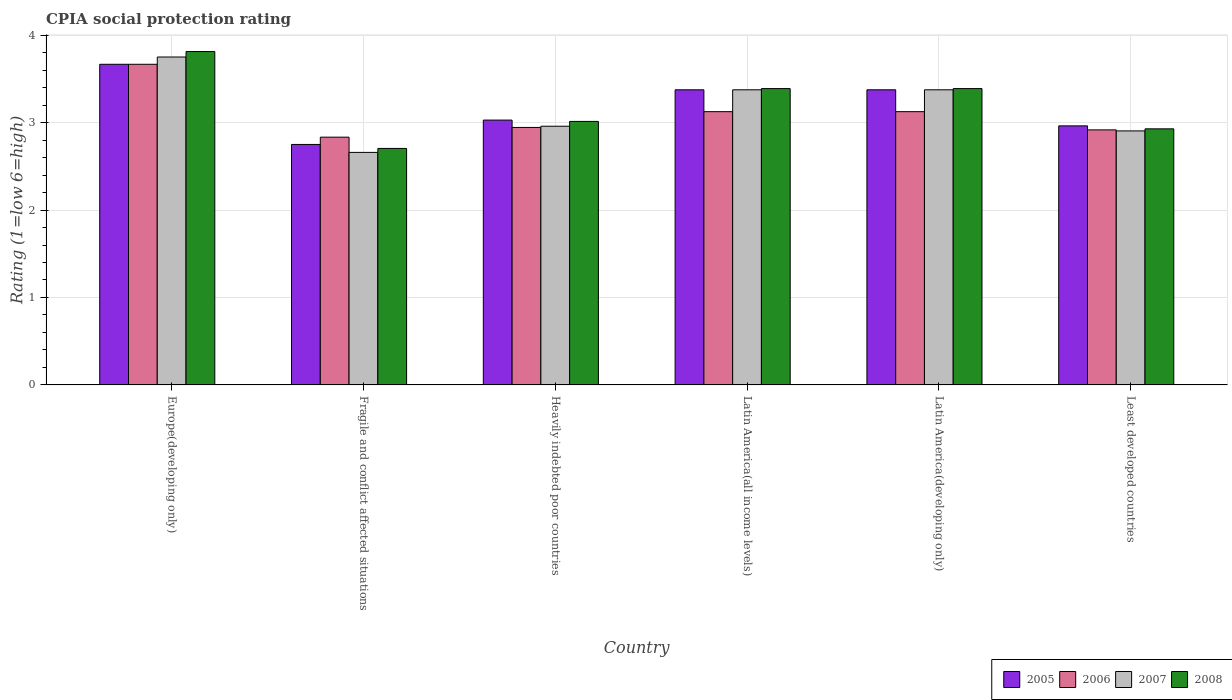Are the number of bars per tick equal to the number of legend labels?
Keep it short and to the point. Yes. How many bars are there on the 4th tick from the left?
Ensure brevity in your answer.  4. How many bars are there on the 5th tick from the right?
Offer a terse response. 4. What is the label of the 3rd group of bars from the left?
Give a very brief answer. Heavily indebted poor countries. What is the CPIA rating in 2006 in Europe(developing only)?
Your answer should be very brief. 3.67. Across all countries, what is the maximum CPIA rating in 2008?
Your answer should be compact. 3.81. Across all countries, what is the minimum CPIA rating in 2006?
Your answer should be very brief. 2.83. In which country was the CPIA rating in 2007 maximum?
Ensure brevity in your answer.  Europe(developing only). In which country was the CPIA rating in 2007 minimum?
Your answer should be very brief. Fragile and conflict affected situations. What is the total CPIA rating in 2006 in the graph?
Provide a succinct answer. 18.61. What is the difference between the CPIA rating in 2006 in Heavily indebted poor countries and that in Latin America(developing only)?
Ensure brevity in your answer.  -0.18. What is the difference between the CPIA rating in 2007 in Europe(developing only) and the CPIA rating in 2005 in Fragile and conflict affected situations?
Your answer should be compact. 1. What is the average CPIA rating in 2006 per country?
Provide a short and direct response. 3.1. What is the difference between the CPIA rating of/in 2005 and CPIA rating of/in 2006 in Latin America(developing only)?
Your response must be concise. 0.25. In how many countries, is the CPIA rating in 2005 greater than 0.2?
Your answer should be very brief. 6. What is the ratio of the CPIA rating in 2008 in Europe(developing only) to that in Latin America(developing only)?
Provide a short and direct response. 1.12. Is the CPIA rating in 2005 in Europe(developing only) less than that in Latin America(all income levels)?
Provide a succinct answer. No. What is the difference between the highest and the second highest CPIA rating in 2006?
Your answer should be very brief. -0.54. What is the difference between the highest and the lowest CPIA rating in 2007?
Make the answer very short. 1.09. Is it the case that in every country, the sum of the CPIA rating in 2006 and CPIA rating in 2007 is greater than the sum of CPIA rating in 2008 and CPIA rating in 2005?
Your response must be concise. No. Is it the case that in every country, the sum of the CPIA rating in 2007 and CPIA rating in 2008 is greater than the CPIA rating in 2005?
Your response must be concise. Yes. How many countries are there in the graph?
Provide a succinct answer. 6. What is the difference between two consecutive major ticks on the Y-axis?
Give a very brief answer. 1. Are the values on the major ticks of Y-axis written in scientific E-notation?
Ensure brevity in your answer.  No. Does the graph contain any zero values?
Give a very brief answer. No. Does the graph contain grids?
Make the answer very short. Yes. How many legend labels are there?
Your response must be concise. 4. What is the title of the graph?
Provide a succinct answer. CPIA social protection rating. Does "1982" appear as one of the legend labels in the graph?
Give a very brief answer. No. What is the label or title of the Y-axis?
Your answer should be very brief. Rating (1=low 6=high). What is the Rating (1=low 6=high) of 2005 in Europe(developing only)?
Your answer should be compact. 3.67. What is the Rating (1=low 6=high) in 2006 in Europe(developing only)?
Your answer should be compact. 3.67. What is the Rating (1=low 6=high) of 2007 in Europe(developing only)?
Provide a succinct answer. 3.75. What is the Rating (1=low 6=high) of 2008 in Europe(developing only)?
Give a very brief answer. 3.81. What is the Rating (1=low 6=high) in 2005 in Fragile and conflict affected situations?
Ensure brevity in your answer.  2.75. What is the Rating (1=low 6=high) in 2006 in Fragile and conflict affected situations?
Make the answer very short. 2.83. What is the Rating (1=low 6=high) of 2007 in Fragile and conflict affected situations?
Offer a terse response. 2.66. What is the Rating (1=low 6=high) in 2008 in Fragile and conflict affected situations?
Provide a short and direct response. 2.7. What is the Rating (1=low 6=high) of 2005 in Heavily indebted poor countries?
Offer a terse response. 3.03. What is the Rating (1=low 6=high) in 2006 in Heavily indebted poor countries?
Give a very brief answer. 2.94. What is the Rating (1=low 6=high) in 2007 in Heavily indebted poor countries?
Make the answer very short. 2.96. What is the Rating (1=low 6=high) of 2008 in Heavily indebted poor countries?
Keep it short and to the point. 3.01. What is the Rating (1=low 6=high) in 2005 in Latin America(all income levels)?
Your answer should be compact. 3.38. What is the Rating (1=low 6=high) of 2006 in Latin America(all income levels)?
Offer a terse response. 3.12. What is the Rating (1=low 6=high) in 2007 in Latin America(all income levels)?
Your response must be concise. 3.38. What is the Rating (1=low 6=high) in 2008 in Latin America(all income levels)?
Offer a terse response. 3.39. What is the Rating (1=low 6=high) in 2005 in Latin America(developing only)?
Offer a very short reply. 3.38. What is the Rating (1=low 6=high) in 2006 in Latin America(developing only)?
Offer a terse response. 3.12. What is the Rating (1=low 6=high) of 2007 in Latin America(developing only)?
Your response must be concise. 3.38. What is the Rating (1=low 6=high) of 2008 in Latin America(developing only)?
Your answer should be compact. 3.39. What is the Rating (1=low 6=high) of 2005 in Least developed countries?
Your answer should be compact. 2.96. What is the Rating (1=low 6=high) of 2006 in Least developed countries?
Offer a very short reply. 2.92. What is the Rating (1=low 6=high) in 2007 in Least developed countries?
Make the answer very short. 2.9. What is the Rating (1=low 6=high) in 2008 in Least developed countries?
Your response must be concise. 2.93. Across all countries, what is the maximum Rating (1=low 6=high) in 2005?
Keep it short and to the point. 3.67. Across all countries, what is the maximum Rating (1=low 6=high) of 2006?
Give a very brief answer. 3.67. Across all countries, what is the maximum Rating (1=low 6=high) of 2007?
Provide a short and direct response. 3.75. Across all countries, what is the maximum Rating (1=low 6=high) of 2008?
Your answer should be compact. 3.81. Across all countries, what is the minimum Rating (1=low 6=high) in 2005?
Your response must be concise. 2.75. Across all countries, what is the minimum Rating (1=low 6=high) of 2006?
Your answer should be very brief. 2.83. Across all countries, what is the minimum Rating (1=low 6=high) of 2007?
Offer a very short reply. 2.66. Across all countries, what is the minimum Rating (1=low 6=high) of 2008?
Your response must be concise. 2.7. What is the total Rating (1=low 6=high) of 2005 in the graph?
Provide a succinct answer. 19.16. What is the total Rating (1=low 6=high) of 2006 in the graph?
Provide a short and direct response. 18.61. What is the total Rating (1=low 6=high) of 2007 in the graph?
Your answer should be very brief. 19.02. What is the total Rating (1=low 6=high) in 2008 in the graph?
Offer a terse response. 19.24. What is the difference between the Rating (1=low 6=high) in 2007 in Europe(developing only) and that in Fragile and conflict affected situations?
Ensure brevity in your answer.  1.09. What is the difference between the Rating (1=low 6=high) in 2008 in Europe(developing only) and that in Fragile and conflict affected situations?
Make the answer very short. 1.11. What is the difference between the Rating (1=low 6=high) of 2005 in Europe(developing only) and that in Heavily indebted poor countries?
Offer a very short reply. 0.64. What is the difference between the Rating (1=low 6=high) of 2006 in Europe(developing only) and that in Heavily indebted poor countries?
Your answer should be compact. 0.72. What is the difference between the Rating (1=low 6=high) of 2007 in Europe(developing only) and that in Heavily indebted poor countries?
Your answer should be compact. 0.79. What is the difference between the Rating (1=low 6=high) of 2008 in Europe(developing only) and that in Heavily indebted poor countries?
Provide a succinct answer. 0.8. What is the difference between the Rating (1=low 6=high) of 2005 in Europe(developing only) and that in Latin America(all income levels)?
Offer a very short reply. 0.29. What is the difference between the Rating (1=low 6=high) in 2006 in Europe(developing only) and that in Latin America(all income levels)?
Your answer should be compact. 0.54. What is the difference between the Rating (1=low 6=high) of 2007 in Europe(developing only) and that in Latin America(all income levels)?
Offer a terse response. 0.38. What is the difference between the Rating (1=low 6=high) of 2008 in Europe(developing only) and that in Latin America(all income levels)?
Your answer should be very brief. 0.42. What is the difference between the Rating (1=low 6=high) in 2005 in Europe(developing only) and that in Latin America(developing only)?
Keep it short and to the point. 0.29. What is the difference between the Rating (1=low 6=high) of 2006 in Europe(developing only) and that in Latin America(developing only)?
Offer a very short reply. 0.54. What is the difference between the Rating (1=low 6=high) of 2008 in Europe(developing only) and that in Latin America(developing only)?
Offer a very short reply. 0.42. What is the difference between the Rating (1=low 6=high) in 2005 in Europe(developing only) and that in Least developed countries?
Your answer should be compact. 0.7. What is the difference between the Rating (1=low 6=high) in 2007 in Europe(developing only) and that in Least developed countries?
Ensure brevity in your answer.  0.85. What is the difference between the Rating (1=low 6=high) of 2008 in Europe(developing only) and that in Least developed countries?
Your answer should be very brief. 0.88. What is the difference between the Rating (1=low 6=high) in 2005 in Fragile and conflict affected situations and that in Heavily indebted poor countries?
Give a very brief answer. -0.28. What is the difference between the Rating (1=low 6=high) in 2006 in Fragile and conflict affected situations and that in Heavily indebted poor countries?
Your answer should be very brief. -0.11. What is the difference between the Rating (1=low 6=high) of 2007 in Fragile and conflict affected situations and that in Heavily indebted poor countries?
Your response must be concise. -0.3. What is the difference between the Rating (1=low 6=high) in 2008 in Fragile and conflict affected situations and that in Heavily indebted poor countries?
Your answer should be very brief. -0.31. What is the difference between the Rating (1=low 6=high) of 2005 in Fragile and conflict affected situations and that in Latin America(all income levels)?
Make the answer very short. -0.62. What is the difference between the Rating (1=low 6=high) in 2006 in Fragile and conflict affected situations and that in Latin America(all income levels)?
Ensure brevity in your answer.  -0.29. What is the difference between the Rating (1=low 6=high) of 2007 in Fragile and conflict affected situations and that in Latin America(all income levels)?
Your response must be concise. -0.72. What is the difference between the Rating (1=low 6=high) in 2008 in Fragile and conflict affected situations and that in Latin America(all income levels)?
Your answer should be very brief. -0.68. What is the difference between the Rating (1=low 6=high) in 2005 in Fragile and conflict affected situations and that in Latin America(developing only)?
Your answer should be very brief. -0.62. What is the difference between the Rating (1=low 6=high) of 2006 in Fragile and conflict affected situations and that in Latin America(developing only)?
Keep it short and to the point. -0.29. What is the difference between the Rating (1=low 6=high) in 2007 in Fragile and conflict affected situations and that in Latin America(developing only)?
Provide a succinct answer. -0.72. What is the difference between the Rating (1=low 6=high) in 2008 in Fragile and conflict affected situations and that in Latin America(developing only)?
Keep it short and to the point. -0.68. What is the difference between the Rating (1=low 6=high) in 2005 in Fragile and conflict affected situations and that in Least developed countries?
Make the answer very short. -0.21. What is the difference between the Rating (1=low 6=high) in 2006 in Fragile and conflict affected situations and that in Least developed countries?
Ensure brevity in your answer.  -0.08. What is the difference between the Rating (1=low 6=high) of 2007 in Fragile and conflict affected situations and that in Least developed countries?
Your answer should be very brief. -0.25. What is the difference between the Rating (1=low 6=high) in 2008 in Fragile and conflict affected situations and that in Least developed countries?
Offer a terse response. -0.22. What is the difference between the Rating (1=low 6=high) of 2005 in Heavily indebted poor countries and that in Latin America(all income levels)?
Keep it short and to the point. -0.35. What is the difference between the Rating (1=low 6=high) in 2006 in Heavily indebted poor countries and that in Latin America(all income levels)?
Provide a short and direct response. -0.18. What is the difference between the Rating (1=low 6=high) in 2007 in Heavily indebted poor countries and that in Latin America(all income levels)?
Provide a short and direct response. -0.42. What is the difference between the Rating (1=low 6=high) of 2008 in Heavily indebted poor countries and that in Latin America(all income levels)?
Your response must be concise. -0.38. What is the difference between the Rating (1=low 6=high) in 2005 in Heavily indebted poor countries and that in Latin America(developing only)?
Offer a very short reply. -0.35. What is the difference between the Rating (1=low 6=high) in 2006 in Heavily indebted poor countries and that in Latin America(developing only)?
Your answer should be compact. -0.18. What is the difference between the Rating (1=low 6=high) of 2007 in Heavily indebted poor countries and that in Latin America(developing only)?
Offer a very short reply. -0.42. What is the difference between the Rating (1=low 6=high) of 2008 in Heavily indebted poor countries and that in Latin America(developing only)?
Your response must be concise. -0.38. What is the difference between the Rating (1=low 6=high) of 2005 in Heavily indebted poor countries and that in Least developed countries?
Offer a very short reply. 0.07. What is the difference between the Rating (1=low 6=high) in 2006 in Heavily indebted poor countries and that in Least developed countries?
Make the answer very short. 0.03. What is the difference between the Rating (1=low 6=high) in 2007 in Heavily indebted poor countries and that in Least developed countries?
Provide a succinct answer. 0.05. What is the difference between the Rating (1=low 6=high) in 2008 in Heavily indebted poor countries and that in Least developed countries?
Offer a terse response. 0.08. What is the difference between the Rating (1=low 6=high) in 2005 in Latin America(all income levels) and that in Latin America(developing only)?
Ensure brevity in your answer.  0. What is the difference between the Rating (1=low 6=high) in 2006 in Latin America(all income levels) and that in Latin America(developing only)?
Your answer should be very brief. 0. What is the difference between the Rating (1=low 6=high) of 2007 in Latin America(all income levels) and that in Latin America(developing only)?
Your answer should be very brief. 0. What is the difference between the Rating (1=low 6=high) in 2008 in Latin America(all income levels) and that in Latin America(developing only)?
Your answer should be very brief. 0. What is the difference between the Rating (1=low 6=high) in 2005 in Latin America(all income levels) and that in Least developed countries?
Your answer should be very brief. 0.41. What is the difference between the Rating (1=low 6=high) in 2006 in Latin America(all income levels) and that in Least developed countries?
Your answer should be very brief. 0.21. What is the difference between the Rating (1=low 6=high) of 2007 in Latin America(all income levels) and that in Least developed countries?
Ensure brevity in your answer.  0.47. What is the difference between the Rating (1=low 6=high) in 2008 in Latin America(all income levels) and that in Least developed countries?
Make the answer very short. 0.46. What is the difference between the Rating (1=low 6=high) of 2005 in Latin America(developing only) and that in Least developed countries?
Your answer should be very brief. 0.41. What is the difference between the Rating (1=low 6=high) of 2006 in Latin America(developing only) and that in Least developed countries?
Your answer should be very brief. 0.21. What is the difference between the Rating (1=low 6=high) of 2007 in Latin America(developing only) and that in Least developed countries?
Make the answer very short. 0.47. What is the difference between the Rating (1=low 6=high) in 2008 in Latin America(developing only) and that in Least developed countries?
Your answer should be very brief. 0.46. What is the difference between the Rating (1=low 6=high) in 2005 in Europe(developing only) and the Rating (1=low 6=high) in 2006 in Fragile and conflict affected situations?
Offer a terse response. 0.83. What is the difference between the Rating (1=low 6=high) of 2005 in Europe(developing only) and the Rating (1=low 6=high) of 2007 in Fragile and conflict affected situations?
Give a very brief answer. 1.01. What is the difference between the Rating (1=low 6=high) in 2005 in Europe(developing only) and the Rating (1=low 6=high) in 2008 in Fragile and conflict affected situations?
Keep it short and to the point. 0.96. What is the difference between the Rating (1=low 6=high) of 2006 in Europe(developing only) and the Rating (1=low 6=high) of 2007 in Fragile and conflict affected situations?
Offer a very short reply. 1.01. What is the difference between the Rating (1=low 6=high) in 2006 in Europe(developing only) and the Rating (1=low 6=high) in 2008 in Fragile and conflict affected situations?
Keep it short and to the point. 0.96. What is the difference between the Rating (1=low 6=high) in 2007 in Europe(developing only) and the Rating (1=low 6=high) in 2008 in Fragile and conflict affected situations?
Your answer should be compact. 1.05. What is the difference between the Rating (1=low 6=high) in 2005 in Europe(developing only) and the Rating (1=low 6=high) in 2006 in Heavily indebted poor countries?
Your answer should be very brief. 0.72. What is the difference between the Rating (1=low 6=high) in 2005 in Europe(developing only) and the Rating (1=low 6=high) in 2007 in Heavily indebted poor countries?
Provide a succinct answer. 0.71. What is the difference between the Rating (1=low 6=high) in 2005 in Europe(developing only) and the Rating (1=low 6=high) in 2008 in Heavily indebted poor countries?
Provide a short and direct response. 0.65. What is the difference between the Rating (1=low 6=high) in 2006 in Europe(developing only) and the Rating (1=low 6=high) in 2007 in Heavily indebted poor countries?
Offer a very short reply. 0.71. What is the difference between the Rating (1=low 6=high) of 2006 in Europe(developing only) and the Rating (1=low 6=high) of 2008 in Heavily indebted poor countries?
Keep it short and to the point. 0.65. What is the difference between the Rating (1=low 6=high) in 2007 in Europe(developing only) and the Rating (1=low 6=high) in 2008 in Heavily indebted poor countries?
Offer a very short reply. 0.74. What is the difference between the Rating (1=low 6=high) in 2005 in Europe(developing only) and the Rating (1=low 6=high) in 2006 in Latin America(all income levels)?
Provide a short and direct response. 0.54. What is the difference between the Rating (1=low 6=high) of 2005 in Europe(developing only) and the Rating (1=low 6=high) of 2007 in Latin America(all income levels)?
Make the answer very short. 0.29. What is the difference between the Rating (1=low 6=high) in 2005 in Europe(developing only) and the Rating (1=low 6=high) in 2008 in Latin America(all income levels)?
Provide a short and direct response. 0.28. What is the difference between the Rating (1=low 6=high) in 2006 in Europe(developing only) and the Rating (1=low 6=high) in 2007 in Latin America(all income levels)?
Keep it short and to the point. 0.29. What is the difference between the Rating (1=low 6=high) in 2006 in Europe(developing only) and the Rating (1=low 6=high) in 2008 in Latin America(all income levels)?
Provide a short and direct response. 0.28. What is the difference between the Rating (1=low 6=high) of 2007 in Europe(developing only) and the Rating (1=low 6=high) of 2008 in Latin America(all income levels)?
Give a very brief answer. 0.36. What is the difference between the Rating (1=low 6=high) in 2005 in Europe(developing only) and the Rating (1=low 6=high) in 2006 in Latin America(developing only)?
Provide a succinct answer. 0.54. What is the difference between the Rating (1=low 6=high) in 2005 in Europe(developing only) and the Rating (1=low 6=high) in 2007 in Latin America(developing only)?
Ensure brevity in your answer.  0.29. What is the difference between the Rating (1=low 6=high) of 2005 in Europe(developing only) and the Rating (1=low 6=high) of 2008 in Latin America(developing only)?
Your answer should be compact. 0.28. What is the difference between the Rating (1=low 6=high) of 2006 in Europe(developing only) and the Rating (1=low 6=high) of 2007 in Latin America(developing only)?
Provide a succinct answer. 0.29. What is the difference between the Rating (1=low 6=high) of 2006 in Europe(developing only) and the Rating (1=low 6=high) of 2008 in Latin America(developing only)?
Your response must be concise. 0.28. What is the difference between the Rating (1=low 6=high) of 2007 in Europe(developing only) and the Rating (1=low 6=high) of 2008 in Latin America(developing only)?
Provide a succinct answer. 0.36. What is the difference between the Rating (1=low 6=high) of 2005 in Europe(developing only) and the Rating (1=low 6=high) of 2006 in Least developed countries?
Keep it short and to the point. 0.75. What is the difference between the Rating (1=low 6=high) in 2005 in Europe(developing only) and the Rating (1=low 6=high) in 2007 in Least developed countries?
Make the answer very short. 0.76. What is the difference between the Rating (1=low 6=high) in 2005 in Europe(developing only) and the Rating (1=low 6=high) in 2008 in Least developed countries?
Ensure brevity in your answer.  0.74. What is the difference between the Rating (1=low 6=high) in 2006 in Europe(developing only) and the Rating (1=low 6=high) in 2007 in Least developed countries?
Provide a succinct answer. 0.76. What is the difference between the Rating (1=low 6=high) in 2006 in Europe(developing only) and the Rating (1=low 6=high) in 2008 in Least developed countries?
Your answer should be very brief. 0.74. What is the difference between the Rating (1=low 6=high) in 2007 in Europe(developing only) and the Rating (1=low 6=high) in 2008 in Least developed countries?
Give a very brief answer. 0.82. What is the difference between the Rating (1=low 6=high) of 2005 in Fragile and conflict affected situations and the Rating (1=low 6=high) of 2006 in Heavily indebted poor countries?
Give a very brief answer. -0.19. What is the difference between the Rating (1=low 6=high) of 2005 in Fragile and conflict affected situations and the Rating (1=low 6=high) of 2007 in Heavily indebted poor countries?
Your response must be concise. -0.21. What is the difference between the Rating (1=low 6=high) of 2005 in Fragile and conflict affected situations and the Rating (1=low 6=high) of 2008 in Heavily indebted poor countries?
Your response must be concise. -0.26. What is the difference between the Rating (1=low 6=high) in 2006 in Fragile and conflict affected situations and the Rating (1=low 6=high) in 2007 in Heavily indebted poor countries?
Provide a succinct answer. -0.12. What is the difference between the Rating (1=low 6=high) of 2006 in Fragile and conflict affected situations and the Rating (1=low 6=high) of 2008 in Heavily indebted poor countries?
Offer a very short reply. -0.18. What is the difference between the Rating (1=low 6=high) of 2007 in Fragile and conflict affected situations and the Rating (1=low 6=high) of 2008 in Heavily indebted poor countries?
Keep it short and to the point. -0.35. What is the difference between the Rating (1=low 6=high) in 2005 in Fragile and conflict affected situations and the Rating (1=low 6=high) in 2006 in Latin America(all income levels)?
Keep it short and to the point. -0.38. What is the difference between the Rating (1=low 6=high) in 2005 in Fragile and conflict affected situations and the Rating (1=low 6=high) in 2007 in Latin America(all income levels)?
Your answer should be very brief. -0.62. What is the difference between the Rating (1=low 6=high) of 2005 in Fragile and conflict affected situations and the Rating (1=low 6=high) of 2008 in Latin America(all income levels)?
Your response must be concise. -0.64. What is the difference between the Rating (1=low 6=high) in 2006 in Fragile and conflict affected situations and the Rating (1=low 6=high) in 2007 in Latin America(all income levels)?
Offer a terse response. -0.54. What is the difference between the Rating (1=low 6=high) of 2006 in Fragile and conflict affected situations and the Rating (1=low 6=high) of 2008 in Latin America(all income levels)?
Offer a terse response. -0.56. What is the difference between the Rating (1=low 6=high) of 2007 in Fragile and conflict affected situations and the Rating (1=low 6=high) of 2008 in Latin America(all income levels)?
Keep it short and to the point. -0.73. What is the difference between the Rating (1=low 6=high) of 2005 in Fragile and conflict affected situations and the Rating (1=low 6=high) of 2006 in Latin America(developing only)?
Ensure brevity in your answer.  -0.38. What is the difference between the Rating (1=low 6=high) in 2005 in Fragile and conflict affected situations and the Rating (1=low 6=high) in 2007 in Latin America(developing only)?
Offer a terse response. -0.62. What is the difference between the Rating (1=low 6=high) of 2005 in Fragile and conflict affected situations and the Rating (1=low 6=high) of 2008 in Latin America(developing only)?
Make the answer very short. -0.64. What is the difference between the Rating (1=low 6=high) in 2006 in Fragile and conflict affected situations and the Rating (1=low 6=high) in 2007 in Latin America(developing only)?
Provide a short and direct response. -0.54. What is the difference between the Rating (1=low 6=high) in 2006 in Fragile and conflict affected situations and the Rating (1=low 6=high) in 2008 in Latin America(developing only)?
Give a very brief answer. -0.56. What is the difference between the Rating (1=low 6=high) in 2007 in Fragile and conflict affected situations and the Rating (1=low 6=high) in 2008 in Latin America(developing only)?
Your response must be concise. -0.73. What is the difference between the Rating (1=low 6=high) of 2005 in Fragile and conflict affected situations and the Rating (1=low 6=high) of 2006 in Least developed countries?
Keep it short and to the point. -0.17. What is the difference between the Rating (1=low 6=high) of 2005 in Fragile and conflict affected situations and the Rating (1=low 6=high) of 2007 in Least developed countries?
Provide a succinct answer. -0.15. What is the difference between the Rating (1=low 6=high) of 2005 in Fragile and conflict affected situations and the Rating (1=low 6=high) of 2008 in Least developed countries?
Make the answer very short. -0.18. What is the difference between the Rating (1=low 6=high) of 2006 in Fragile and conflict affected situations and the Rating (1=low 6=high) of 2007 in Least developed countries?
Your answer should be very brief. -0.07. What is the difference between the Rating (1=low 6=high) in 2006 in Fragile and conflict affected situations and the Rating (1=low 6=high) in 2008 in Least developed countries?
Provide a short and direct response. -0.1. What is the difference between the Rating (1=low 6=high) in 2007 in Fragile and conflict affected situations and the Rating (1=low 6=high) in 2008 in Least developed countries?
Your response must be concise. -0.27. What is the difference between the Rating (1=low 6=high) of 2005 in Heavily indebted poor countries and the Rating (1=low 6=high) of 2006 in Latin America(all income levels)?
Make the answer very short. -0.1. What is the difference between the Rating (1=low 6=high) of 2005 in Heavily indebted poor countries and the Rating (1=low 6=high) of 2007 in Latin America(all income levels)?
Give a very brief answer. -0.35. What is the difference between the Rating (1=low 6=high) of 2005 in Heavily indebted poor countries and the Rating (1=low 6=high) of 2008 in Latin America(all income levels)?
Offer a very short reply. -0.36. What is the difference between the Rating (1=low 6=high) in 2006 in Heavily indebted poor countries and the Rating (1=low 6=high) in 2007 in Latin America(all income levels)?
Keep it short and to the point. -0.43. What is the difference between the Rating (1=low 6=high) of 2006 in Heavily indebted poor countries and the Rating (1=low 6=high) of 2008 in Latin America(all income levels)?
Your answer should be compact. -0.44. What is the difference between the Rating (1=low 6=high) in 2007 in Heavily indebted poor countries and the Rating (1=low 6=high) in 2008 in Latin America(all income levels)?
Provide a succinct answer. -0.43. What is the difference between the Rating (1=low 6=high) of 2005 in Heavily indebted poor countries and the Rating (1=low 6=high) of 2006 in Latin America(developing only)?
Your answer should be compact. -0.1. What is the difference between the Rating (1=low 6=high) in 2005 in Heavily indebted poor countries and the Rating (1=low 6=high) in 2007 in Latin America(developing only)?
Your response must be concise. -0.35. What is the difference between the Rating (1=low 6=high) in 2005 in Heavily indebted poor countries and the Rating (1=low 6=high) in 2008 in Latin America(developing only)?
Your response must be concise. -0.36. What is the difference between the Rating (1=low 6=high) of 2006 in Heavily indebted poor countries and the Rating (1=low 6=high) of 2007 in Latin America(developing only)?
Your answer should be very brief. -0.43. What is the difference between the Rating (1=low 6=high) in 2006 in Heavily indebted poor countries and the Rating (1=low 6=high) in 2008 in Latin America(developing only)?
Give a very brief answer. -0.44. What is the difference between the Rating (1=low 6=high) in 2007 in Heavily indebted poor countries and the Rating (1=low 6=high) in 2008 in Latin America(developing only)?
Offer a terse response. -0.43. What is the difference between the Rating (1=low 6=high) in 2005 in Heavily indebted poor countries and the Rating (1=low 6=high) in 2006 in Least developed countries?
Your response must be concise. 0.11. What is the difference between the Rating (1=low 6=high) in 2005 in Heavily indebted poor countries and the Rating (1=low 6=high) in 2007 in Least developed countries?
Keep it short and to the point. 0.12. What is the difference between the Rating (1=low 6=high) of 2005 in Heavily indebted poor countries and the Rating (1=low 6=high) of 2008 in Least developed countries?
Provide a succinct answer. 0.1. What is the difference between the Rating (1=low 6=high) in 2006 in Heavily indebted poor countries and the Rating (1=low 6=high) in 2007 in Least developed countries?
Your answer should be very brief. 0.04. What is the difference between the Rating (1=low 6=high) of 2006 in Heavily indebted poor countries and the Rating (1=low 6=high) of 2008 in Least developed countries?
Give a very brief answer. 0.02. What is the difference between the Rating (1=low 6=high) in 2007 in Heavily indebted poor countries and the Rating (1=low 6=high) in 2008 in Least developed countries?
Make the answer very short. 0.03. What is the difference between the Rating (1=low 6=high) of 2005 in Latin America(all income levels) and the Rating (1=low 6=high) of 2007 in Latin America(developing only)?
Offer a terse response. 0. What is the difference between the Rating (1=low 6=high) of 2005 in Latin America(all income levels) and the Rating (1=low 6=high) of 2008 in Latin America(developing only)?
Your response must be concise. -0.01. What is the difference between the Rating (1=low 6=high) in 2006 in Latin America(all income levels) and the Rating (1=low 6=high) in 2007 in Latin America(developing only)?
Your response must be concise. -0.25. What is the difference between the Rating (1=low 6=high) of 2006 in Latin America(all income levels) and the Rating (1=low 6=high) of 2008 in Latin America(developing only)?
Your response must be concise. -0.26. What is the difference between the Rating (1=low 6=high) in 2007 in Latin America(all income levels) and the Rating (1=low 6=high) in 2008 in Latin America(developing only)?
Your answer should be compact. -0.01. What is the difference between the Rating (1=low 6=high) in 2005 in Latin America(all income levels) and the Rating (1=low 6=high) in 2006 in Least developed countries?
Give a very brief answer. 0.46. What is the difference between the Rating (1=low 6=high) in 2005 in Latin America(all income levels) and the Rating (1=low 6=high) in 2007 in Least developed countries?
Keep it short and to the point. 0.47. What is the difference between the Rating (1=low 6=high) in 2005 in Latin America(all income levels) and the Rating (1=low 6=high) in 2008 in Least developed countries?
Keep it short and to the point. 0.45. What is the difference between the Rating (1=low 6=high) in 2006 in Latin America(all income levels) and the Rating (1=low 6=high) in 2007 in Least developed countries?
Your answer should be very brief. 0.22. What is the difference between the Rating (1=low 6=high) of 2006 in Latin America(all income levels) and the Rating (1=low 6=high) of 2008 in Least developed countries?
Offer a very short reply. 0.2. What is the difference between the Rating (1=low 6=high) in 2007 in Latin America(all income levels) and the Rating (1=low 6=high) in 2008 in Least developed countries?
Keep it short and to the point. 0.45. What is the difference between the Rating (1=low 6=high) in 2005 in Latin America(developing only) and the Rating (1=low 6=high) in 2006 in Least developed countries?
Make the answer very short. 0.46. What is the difference between the Rating (1=low 6=high) of 2005 in Latin America(developing only) and the Rating (1=low 6=high) of 2007 in Least developed countries?
Your answer should be very brief. 0.47. What is the difference between the Rating (1=low 6=high) of 2005 in Latin America(developing only) and the Rating (1=low 6=high) of 2008 in Least developed countries?
Your response must be concise. 0.45. What is the difference between the Rating (1=low 6=high) of 2006 in Latin America(developing only) and the Rating (1=low 6=high) of 2007 in Least developed countries?
Your answer should be compact. 0.22. What is the difference between the Rating (1=low 6=high) of 2006 in Latin America(developing only) and the Rating (1=low 6=high) of 2008 in Least developed countries?
Ensure brevity in your answer.  0.2. What is the difference between the Rating (1=low 6=high) of 2007 in Latin America(developing only) and the Rating (1=low 6=high) of 2008 in Least developed countries?
Offer a terse response. 0.45. What is the average Rating (1=low 6=high) of 2005 per country?
Make the answer very short. 3.19. What is the average Rating (1=low 6=high) in 2006 per country?
Make the answer very short. 3.1. What is the average Rating (1=low 6=high) of 2007 per country?
Ensure brevity in your answer.  3.17. What is the average Rating (1=low 6=high) in 2008 per country?
Ensure brevity in your answer.  3.21. What is the difference between the Rating (1=low 6=high) of 2005 and Rating (1=low 6=high) of 2007 in Europe(developing only)?
Your answer should be compact. -0.08. What is the difference between the Rating (1=low 6=high) in 2005 and Rating (1=low 6=high) in 2008 in Europe(developing only)?
Give a very brief answer. -0.15. What is the difference between the Rating (1=low 6=high) of 2006 and Rating (1=low 6=high) of 2007 in Europe(developing only)?
Make the answer very short. -0.08. What is the difference between the Rating (1=low 6=high) of 2006 and Rating (1=low 6=high) of 2008 in Europe(developing only)?
Make the answer very short. -0.15. What is the difference between the Rating (1=low 6=high) in 2007 and Rating (1=low 6=high) in 2008 in Europe(developing only)?
Your response must be concise. -0.06. What is the difference between the Rating (1=low 6=high) in 2005 and Rating (1=low 6=high) in 2006 in Fragile and conflict affected situations?
Provide a succinct answer. -0.08. What is the difference between the Rating (1=low 6=high) in 2005 and Rating (1=low 6=high) in 2007 in Fragile and conflict affected situations?
Your answer should be very brief. 0.09. What is the difference between the Rating (1=low 6=high) in 2005 and Rating (1=low 6=high) in 2008 in Fragile and conflict affected situations?
Keep it short and to the point. 0.05. What is the difference between the Rating (1=low 6=high) in 2006 and Rating (1=low 6=high) in 2007 in Fragile and conflict affected situations?
Give a very brief answer. 0.17. What is the difference between the Rating (1=low 6=high) in 2006 and Rating (1=low 6=high) in 2008 in Fragile and conflict affected situations?
Ensure brevity in your answer.  0.13. What is the difference between the Rating (1=low 6=high) in 2007 and Rating (1=low 6=high) in 2008 in Fragile and conflict affected situations?
Give a very brief answer. -0.05. What is the difference between the Rating (1=low 6=high) in 2005 and Rating (1=low 6=high) in 2006 in Heavily indebted poor countries?
Ensure brevity in your answer.  0.08. What is the difference between the Rating (1=low 6=high) of 2005 and Rating (1=low 6=high) of 2007 in Heavily indebted poor countries?
Give a very brief answer. 0.07. What is the difference between the Rating (1=low 6=high) in 2005 and Rating (1=low 6=high) in 2008 in Heavily indebted poor countries?
Provide a short and direct response. 0.02. What is the difference between the Rating (1=low 6=high) in 2006 and Rating (1=low 6=high) in 2007 in Heavily indebted poor countries?
Make the answer very short. -0.01. What is the difference between the Rating (1=low 6=high) of 2006 and Rating (1=low 6=high) of 2008 in Heavily indebted poor countries?
Give a very brief answer. -0.07. What is the difference between the Rating (1=low 6=high) of 2007 and Rating (1=low 6=high) of 2008 in Heavily indebted poor countries?
Keep it short and to the point. -0.06. What is the difference between the Rating (1=low 6=high) in 2005 and Rating (1=low 6=high) in 2007 in Latin America(all income levels)?
Offer a very short reply. 0. What is the difference between the Rating (1=low 6=high) in 2005 and Rating (1=low 6=high) in 2008 in Latin America(all income levels)?
Ensure brevity in your answer.  -0.01. What is the difference between the Rating (1=low 6=high) in 2006 and Rating (1=low 6=high) in 2007 in Latin America(all income levels)?
Ensure brevity in your answer.  -0.25. What is the difference between the Rating (1=low 6=high) in 2006 and Rating (1=low 6=high) in 2008 in Latin America(all income levels)?
Your answer should be compact. -0.26. What is the difference between the Rating (1=low 6=high) of 2007 and Rating (1=low 6=high) of 2008 in Latin America(all income levels)?
Ensure brevity in your answer.  -0.01. What is the difference between the Rating (1=low 6=high) of 2005 and Rating (1=low 6=high) of 2008 in Latin America(developing only)?
Give a very brief answer. -0.01. What is the difference between the Rating (1=low 6=high) in 2006 and Rating (1=low 6=high) in 2008 in Latin America(developing only)?
Provide a short and direct response. -0.26. What is the difference between the Rating (1=low 6=high) in 2007 and Rating (1=low 6=high) in 2008 in Latin America(developing only)?
Your answer should be very brief. -0.01. What is the difference between the Rating (1=low 6=high) of 2005 and Rating (1=low 6=high) of 2006 in Least developed countries?
Your response must be concise. 0.05. What is the difference between the Rating (1=low 6=high) of 2005 and Rating (1=low 6=high) of 2007 in Least developed countries?
Your response must be concise. 0.06. What is the difference between the Rating (1=low 6=high) in 2005 and Rating (1=low 6=high) in 2008 in Least developed countries?
Provide a short and direct response. 0.03. What is the difference between the Rating (1=low 6=high) in 2006 and Rating (1=low 6=high) in 2007 in Least developed countries?
Your answer should be compact. 0.01. What is the difference between the Rating (1=low 6=high) of 2006 and Rating (1=low 6=high) of 2008 in Least developed countries?
Make the answer very short. -0.01. What is the difference between the Rating (1=low 6=high) in 2007 and Rating (1=low 6=high) in 2008 in Least developed countries?
Ensure brevity in your answer.  -0.02. What is the ratio of the Rating (1=low 6=high) in 2005 in Europe(developing only) to that in Fragile and conflict affected situations?
Ensure brevity in your answer.  1.33. What is the ratio of the Rating (1=low 6=high) of 2006 in Europe(developing only) to that in Fragile and conflict affected situations?
Your answer should be compact. 1.29. What is the ratio of the Rating (1=low 6=high) in 2007 in Europe(developing only) to that in Fragile and conflict affected situations?
Provide a succinct answer. 1.41. What is the ratio of the Rating (1=low 6=high) in 2008 in Europe(developing only) to that in Fragile and conflict affected situations?
Your answer should be very brief. 1.41. What is the ratio of the Rating (1=low 6=high) of 2005 in Europe(developing only) to that in Heavily indebted poor countries?
Provide a short and direct response. 1.21. What is the ratio of the Rating (1=low 6=high) of 2006 in Europe(developing only) to that in Heavily indebted poor countries?
Your answer should be very brief. 1.25. What is the ratio of the Rating (1=low 6=high) in 2007 in Europe(developing only) to that in Heavily indebted poor countries?
Keep it short and to the point. 1.27. What is the ratio of the Rating (1=low 6=high) of 2008 in Europe(developing only) to that in Heavily indebted poor countries?
Keep it short and to the point. 1.27. What is the ratio of the Rating (1=low 6=high) in 2005 in Europe(developing only) to that in Latin America(all income levels)?
Your answer should be very brief. 1.09. What is the ratio of the Rating (1=low 6=high) in 2006 in Europe(developing only) to that in Latin America(all income levels)?
Your answer should be compact. 1.17. What is the ratio of the Rating (1=low 6=high) of 2008 in Europe(developing only) to that in Latin America(all income levels)?
Your response must be concise. 1.12. What is the ratio of the Rating (1=low 6=high) of 2005 in Europe(developing only) to that in Latin America(developing only)?
Give a very brief answer. 1.09. What is the ratio of the Rating (1=low 6=high) of 2006 in Europe(developing only) to that in Latin America(developing only)?
Keep it short and to the point. 1.17. What is the ratio of the Rating (1=low 6=high) in 2007 in Europe(developing only) to that in Latin America(developing only)?
Your response must be concise. 1.11. What is the ratio of the Rating (1=low 6=high) in 2005 in Europe(developing only) to that in Least developed countries?
Ensure brevity in your answer.  1.24. What is the ratio of the Rating (1=low 6=high) in 2006 in Europe(developing only) to that in Least developed countries?
Ensure brevity in your answer.  1.26. What is the ratio of the Rating (1=low 6=high) of 2007 in Europe(developing only) to that in Least developed countries?
Make the answer very short. 1.29. What is the ratio of the Rating (1=low 6=high) of 2008 in Europe(developing only) to that in Least developed countries?
Your response must be concise. 1.3. What is the ratio of the Rating (1=low 6=high) in 2005 in Fragile and conflict affected situations to that in Heavily indebted poor countries?
Provide a short and direct response. 0.91. What is the ratio of the Rating (1=low 6=high) in 2006 in Fragile and conflict affected situations to that in Heavily indebted poor countries?
Make the answer very short. 0.96. What is the ratio of the Rating (1=low 6=high) of 2007 in Fragile and conflict affected situations to that in Heavily indebted poor countries?
Offer a terse response. 0.9. What is the ratio of the Rating (1=low 6=high) of 2008 in Fragile and conflict affected situations to that in Heavily indebted poor countries?
Provide a succinct answer. 0.9. What is the ratio of the Rating (1=low 6=high) of 2005 in Fragile and conflict affected situations to that in Latin America(all income levels)?
Make the answer very short. 0.81. What is the ratio of the Rating (1=low 6=high) of 2006 in Fragile and conflict affected situations to that in Latin America(all income levels)?
Keep it short and to the point. 0.91. What is the ratio of the Rating (1=low 6=high) in 2007 in Fragile and conflict affected situations to that in Latin America(all income levels)?
Your response must be concise. 0.79. What is the ratio of the Rating (1=low 6=high) in 2008 in Fragile and conflict affected situations to that in Latin America(all income levels)?
Your response must be concise. 0.8. What is the ratio of the Rating (1=low 6=high) in 2005 in Fragile and conflict affected situations to that in Latin America(developing only)?
Ensure brevity in your answer.  0.81. What is the ratio of the Rating (1=low 6=high) of 2006 in Fragile and conflict affected situations to that in Latin America(developing only)?
Your answer should be very brief. 0.91. What is the ratio of the Rating (1=low 6=high) in 2007 in Fragile and conflict affected situations to that in Latin America(developing only)?
Make the answer very short. 0.79. What is the ratio of the Rating (1=low 6=high) of 2008 in Fragile and conflict affected situations to that in Latin America(developing only)?
Your answer should be compact. 0.8. What is the ratio of the Rating (1=low 6=high) in 2005 in Fragile and conflict affected situations to that in Least developed countries?
Make the answer very short. 0.93. What is the ratio of the Rating (1=low 6=high) in 2006 in Fragile and conflict affected situations to that in Least developed countries?
Offer a terse response. 0.97. What is the ratio of the Rating (1=low 6=high) of 2007 in Fragile and conflict affected situations to that in Least developed countries?
Offer a very short reply. 0.92. What is the ratio of the Rating (1=low 6=high) of 2008 in Fragile and conflict affected situations to that in Least developed countries?
Your answer should be compact. 0.92. What is the ratio of the Rating (1=low 6=high) in 2005 in Heavily indebted poor countries to that in Latin America(all income levels)?
Offer a terse response. 0.9. What is the ratio of the Rating (1=low 6=high) of 2006 in Heavily indebted poor countries to that in Latin America(all income levels)?
Your response must be concise. 0.94. What is the ratio of the Rating (1=low 6=high) of 2007 in Heavily indebted poor countries to that in Latin America(all income levels)?
Your response must be concise. 0.88. What is the ratio of the Rating (1=low 6=high) in 2008 in Heavily indebted poor countries to that in Latin America(all income levels)?
Offer a very short reply. 0.89. What is the ratio of the Rating (1=low 6=high) of 2005 in Heavily indebted poor countries to that in Latin America(developing only)?
Provide a short and direct response. 0.9. What is the ratio of the Rating (1=low 6=high) in 2006 in Heavily indebted poor countries to that in Latin America(developing only)?
Your answer should be compact. 0.94. What is the ratio of the Rating (1=low 6=high) in 2007 in Heavily indebted poor countries to that in Latin America(developing only)?
Ensure brevity in your answer.  0.88. What is the ratio of the Rating (1=low 6=high) of 2008 in Heavily indebted poor countries to that in Latin America(developing only)?
Your answer should be compact. 0.89. What is the ratio of the Rating (1=low 6=high) of 2005 in Heavily indebted poor countries to that in Least developed countries?
Your answer should be compact. 1.02. What is the ratio of the Rating (1=low 6=high) in 2006 in Heavily indebted poor countries to that in Least developed countries?
Your answer should be very brief. 1.01. What is the ratio of the Rating (1=low 6=high) in 2007 in Heavily indebted poor countries to that in Least developed countries?
Your answer should be very brief. 1.02. What is the ratio of the Rating (1=low 6=high) in 2008 in Heavily indebted poor countries to that in Least developed countries?
Your answer should be very brief. 1.03. What is the ratio of the Rating (1=low 6=high) of 2006 in Latin America(all income levels) to that in Latin America(developing only)?
Give a very brief answer. 1. What is the ratio of the Rating (1=low 6=high) of 2005 in Latin America(all income levels) to that in Least developed countries?
Make the answer very short. 1.14. What is the ratio of the Rating (1=low 6=high) in 2006 in Latin America(all income levels) to that in Least developed countries?
Your answer should be compact. 1.07. What is the ratio of the Rating (1=low 6=high) in 2007 in Latin America(all income levels) to that in Least developed countries?
Offer a terse response. 1.16. What is the ratio of the Rating (1=low 6=high) in 2008 in Latin America(all income levels) to that in Least developed countries?
Your answer should be compact. 1.16. What is the ratio of the Rating (1=low 6=high) of 2005 in Latin America(developing only) to that in Least developed countries?
Offer a very short reply. 1.14. What is the ratio of the Rating (1=low 6=high) in 2006 in Latin America(developing only) to that in Least developed countries?
Make the answer very short. 1.07. What is the ratio of the Rating (1=low 6=high) of 2007 in Latin America(developing only) to that in Least developed countries?
Make the answer very short. 1.16. What is the ratio of the Rating (1=low 6=high) in 2008 in Latin America(developing only) to that in Least developed countries?
Keep it short and to the point. 1.16. What is the difference between the highest and the second highest Rating (1=low 6=high) in 2005?
Offer a terse response. 0.29. What is the difference between the highest and the second highest Rating (1=low 6=high) in 2006?
Your response must be concise. 0.54. What is the difference between the highest and the second highest Rating (1=low 6=high) of 2007?
Your response must be concise. 0.38. What is the difference between the highest and the second highest Rating (1=low 6=high) of 2008?
Ensure brevity in your answer.  0.42. What is the difference between the highest and the lowest Rating (1=low 6=high) of 2005?
Offer a terse response. 0.92. What is the difference between the highest and the lowest Rating (1=low 6=high) of 2008?
Your response must be concise. 1.11. 